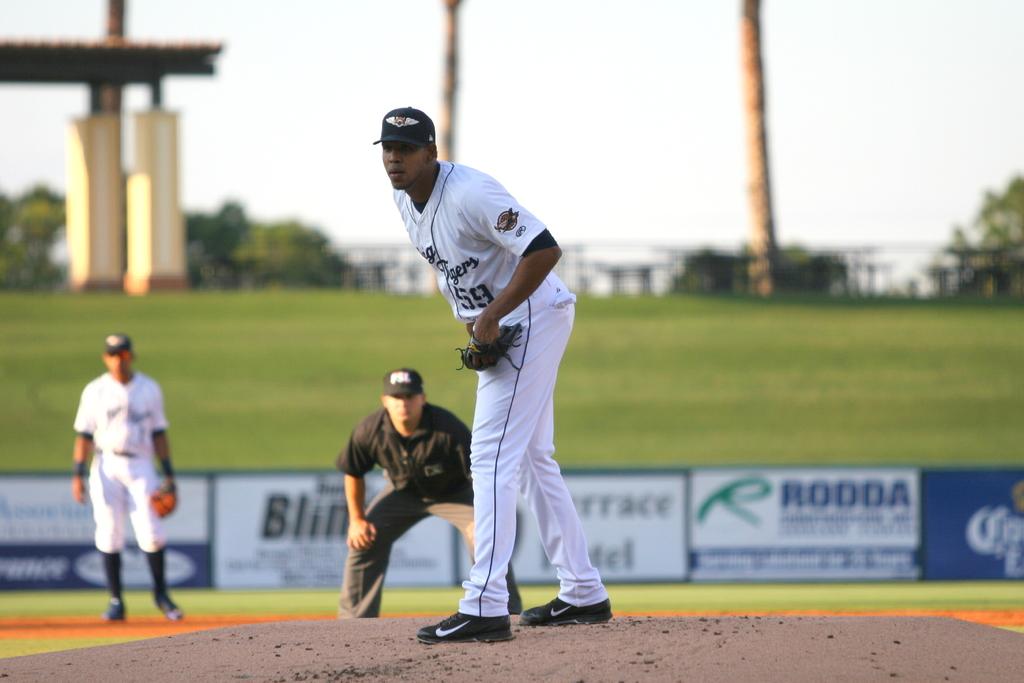This cricket play ground?
Give a very brief answer. No. 